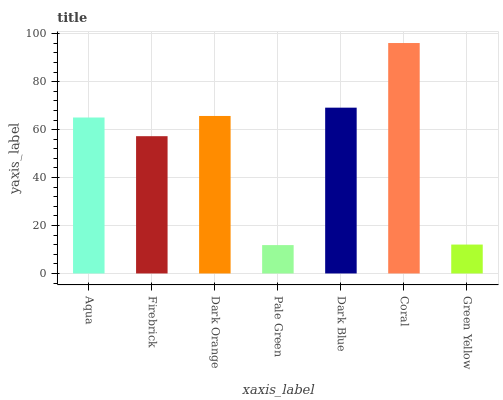Is Pale Green the minimum?
Answer yes or no. Yes. Is Coral the maximum?
Answer yes or no. Yes. Is Firebrick the minimum?
Answer yes or no. No. Is Firebrick the maximum?
Answer yes or no. No. Is Aqua greater than Firebrick?
Answer yes or no. Yes. Is Firebrick less than Aqua?
Answer yes or no. Yes. Is Firebrick greater than Aqua?
Answer yes or no. No. Is Aqua less than Firebrick?
Answer yes or no. No. Is Aqua the high median?
Answer yes or no. Yes. Is Aqua the low median?
Answer yes or no. Yes. Is Firebrick the high median?
Answer yes or no. No. Is Dark Orange the low median?
Answer yes or no. No. 